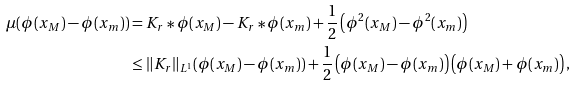<formula> <loc_0><loc_0><loc_500><loc_500>\mu ( \phi ( x _ { M } ) - \phi ( x _ { m } ) ) & = K _ { r } * \phi ( x _ { M } ) - K _ { r } * \phi ( x _ { m } ) + \frac { 1 } { 2 } \left ( \phi ^ { 2 } ( x _ { M } ) - \phi ^ { 2 } ( x _ { m } ) \right ) \\ & \leq \| K _ { r } \| _ { L ^ { 1 } } ( \phi ( x _ { M } ) - \phi ( x _ { m } ) ) + \frac { 1 } { 2 } \left ( \phi ( x _ { M } ) - \phi ( x _ { m } ) \right ) \left ( \phi ( x _ { M } ) + \phi ( x _ { m } ) \right ) ,</formula> 